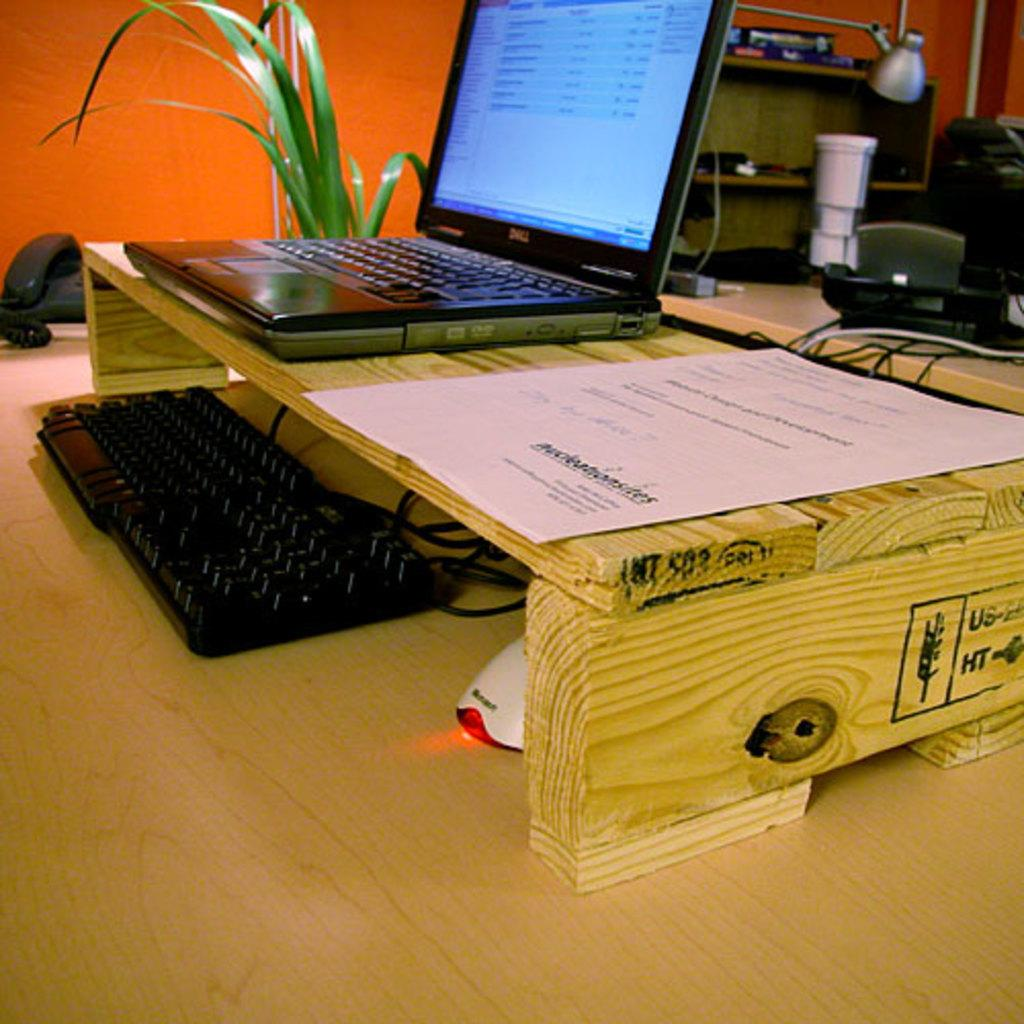What is the main object in the foreground of the image? There is a laptop in the foreground of the image. What other objects are in the foreground of the image? Papers, a keyboard, a mouse, a telephone, and a table are in the foreground of the image. What type of furniture is present in the foreground of the image? There is a table in the foreground of the image. What is visible in the background of the image? There is a table lamp and unspecified objects in the background of the image. Can you see the mother watering the flower in the image? There is no mother or flower present in the image. 